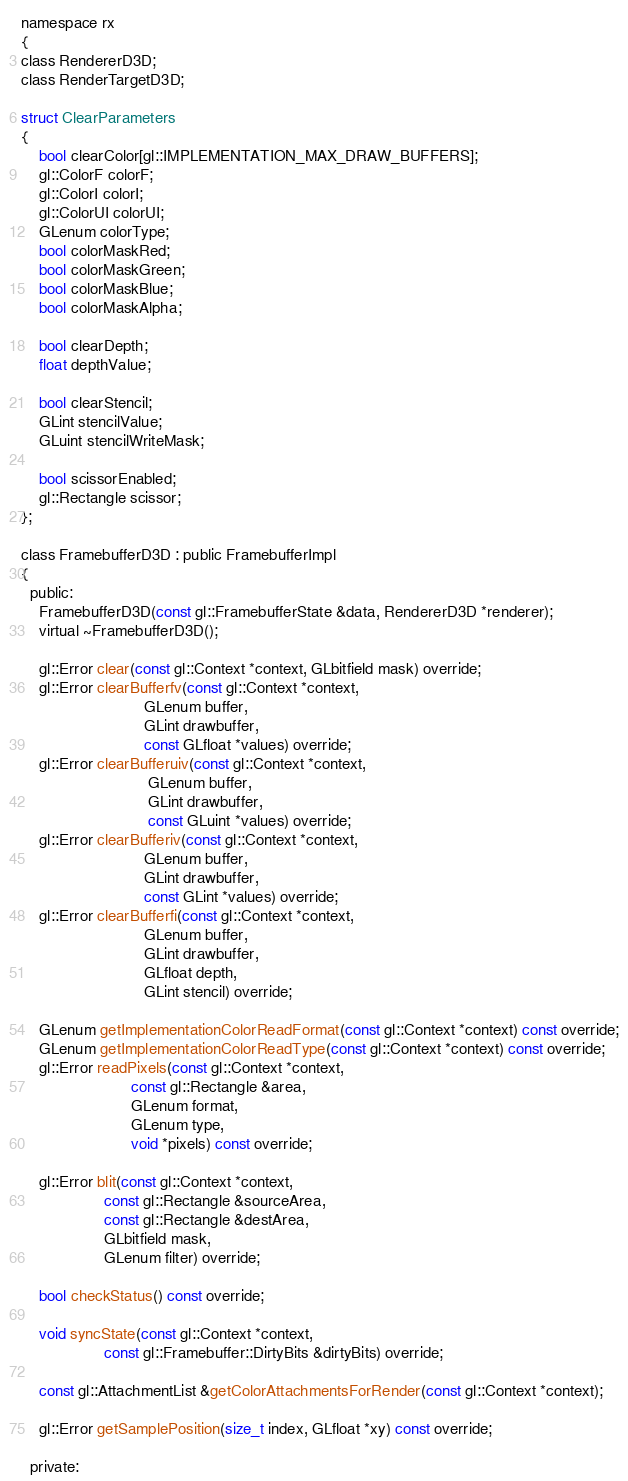Convert code to text. <code><loc_0><loc_0><loc_500><loc_500><_C_>
namespace rx
{
class RendererD3D;
class RenderTargetD3D;

struct ClearParameters
{
    bool clearColor[gl::IMPLEMENTATION_MAX_DRAW_BUFFERS];
    gl::ColorF colorF;
    gl::ColorI colorI;
    gl::ColorUI colorUI;
    GLenum colorType;
    bool colorMaskRed;
    bool colorMaskGreen;
    bool colorMaskBlue;
    bool colorMaskAlpha;

    bool clearDepth;
    float depthValue;

    bool clearStencil;
    GLint stencilValue;
    GLuint stencilWriteMask;

    bool scissorEnabled;
    gl::Rectangle scissor;
};

class FramebufferD3D : public FramebufferImpl
{
  public:
    FramebufferD3D(const gl::FramebufferState &data, RendererD3D *renderer);
    virtual ~FramebufferD3D();

    gl::Error clear(const gl::Context *context, GLbitfield mask) override;
    gl::Error clearBufferfv(const gl::Context *context,
                            GLenum buffer,
                            GLint drawbuffer,
                            const GLfloat *values) override;
    gl::Error clearBufferuiv(const gl::Context *context,
                             GLenum buffer,
                             GLint drawbuffer,
                             const GLuint *values) override;
    gl::Error clearBufferiv(const gl::Context *context,
                            GLenum buffer,
                            GLint drawbuffer,
                            const GLint *values) override;
    gl::Error clearBufferfi(const gl::Context *context,
                            GLenum buffer,
                            GLint drawbuffer,
                            GLfloat depth,
                            GLint stencil) override;

    GLenum getImplementationColorReadFormat(const gl::Context *context) const override;
    GLenum getImplementationColorReadType(const gl::Context *context) const override;
    gl::Error readPixels(const gl::Context *context,
                         const gl::Rectangle &area,
                         GLenum format,
                         GLenum type,
                         void *pixels) const override;

    gl::Error blit(const gl::Context *context,
                   const gl::Rectangle &sourceArea,
                   const gl::Rectangle &destArea,
                   GLbitfield mask,
                   GLenum filter) override;

    bool checkStatus() const override;

    void syncState(const gl::Context *context,
                   const gl::Framebuffer::DirtyBits &dirtyBits) override;

    const gl::AttachmentList &getColorAttachmentsForRender(const gl::Context *context);

    gl::Error getSamplePosition(size_t index, GLfloat *xy) const override;

  private:</code> 